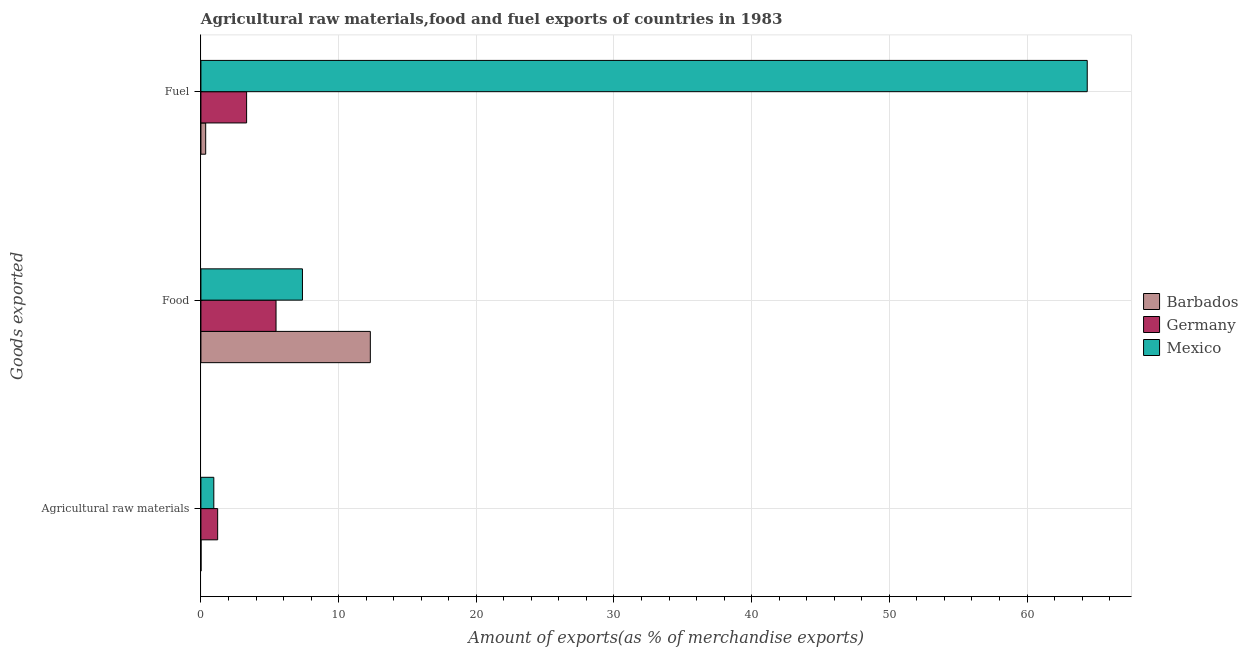How many different coloured bars are there?
Give a very brief answer. 3. Are the number of bars per tick equal to the number of legend labels?
Offer a very short reply. Yes. Are the number of bars on each tick of the Y-axis equal?
Provide a short and direct response. Yes. What is the label of the 1st group of bars from the top?
Offer a terse response. Fuel. What is the percentage of raw materials exports in Mexico?
Provide a succinct answer. 0.94. Across all countries, what is the maximum percentage of raw materials exports?
Make the answer very short. 1.22. Across all countries, what is the minimum percentage of raw materials exports?
Your response must be concise. 0.01. In which country was the percentage of fuel exports maximum?
Offer a terse response. Mexico. In which country was the percentage of fuel exports minimum?
Your response must be concise. Barbados. What is the total percentage of raw materials exports in the graph?
Make the answer very short. 2.16. What is the difference between the percentage of raw materials exports in Germany and that in Barbados?
Offer a very short reply. 1.21. What is the difference between the percentage of fuel exports in Mexico and the percentage of raw materials exports in Germany?
Your response must be concise. 63.15. What is the average percentage of food exports per country?
Provide a short and direct response. 8.38. What is the difference between the percentage of fuel exports and percentage of raw materials exports in Germany?
Provide a short and direct response. 2.1. In how many countries, is the percentage of fuel exports greater than 54 %?
Keep it short and to the point. 1. What is the ratio of the percentage of fuel exports in Germany to that in Mexico?
Provide a short and direct response. 0.05. What is the difference between the highest and the second highest percentage of raw materials exports?
Your answer should be compact. 0.28. What is the difference between the highest and the lowest percentage of food exports?
Provide a succinct answer. 6.85. Are all the bars in the graph horizontal?
Provide a short and direct response. Yes. Are the values on the major ticks of X-axis written in scientific E-notation?
Your answer should be very brief. No. How are the legend labels stacked?
Your response must be concise. Vertical. What is the title of the graph?
Ensure brevity in your answer.  Agricultural raw materials,food and fuel exports of countries in 1983. What is the label or title of the X-axis?
Your response must be concise. Amount of exports(as % of merchandise exports). What is the label or title of the Y-axis?
Keep it short and to the point. Goods exported. What is the Amount of exports(as % of merchandise exports) of Barbados in Agricultural raw materials?
Give a very brief answer. 0.01. What is the Amount of exports(as % of merchandise exports) of Germany in Agricultural raw materials?
Ensure brevity in your answer.  1.22. What is the Amount of exports(as % of merchandise exports) in Mexico in Agricultural raw materials?
Provide a short and direct response. 0.94. What is the Amount of exports(as % of merchandise exports) of Barbados in Food?
Give a very brief answer. 12.3. What is the Amount of exports(as % of merchandise exports) of Germany in Food?
Make the answer very short. 5.46. What is the Amount of exports(as % of merchandise exports) of Mexico in Food?
Provide a succinct answer. 7.37. What is the Amount of exports(as % of merchandise exports) of Barbados in Fuel?
Your response must be concise. 0.35. What is the Amount of exports(as % of merchandise exports) of Germany in Fuel?
Offer a terse response. 3.32. What is the Amount of exports(as % of merchandise exports) in Mexico in Fuel?
Offer a terse response. 64.37. Across all Goods exported, what is the maximum Amount of exports(as % of merchandise exports) of Barbados?
Provide a succinct answer. 12.3. Across all Goods exported, what is the maximum Amount of exports(as % of merchandise exports) of Germany?
Ensure brevity in your answer.  5.46. Across all Goods exported, what is the maximum Amount of exports(as % of merchandise exports) of Mexico?
Give a very brief answer. 64.37. Across all Goods exported, what is the minimum Amount of exports(as % of merchandise exports) of Barbados?
Provide a short and direct response. 0.01. Across all Goods exported, what is the minimum Amount of exports(as % of merchandise exports) of Germany?
Your answer should be very brief. 1.22. Across all Goods exported, what is the minimum Amount of exports(as % of merchandise exports) of Mexico?
Provide a short and direct response. 0.94. What is the total Amount of exports(as % of merchandise exports) of Barbados in the graph?
Provide a short and direct response. 12.66. What is the total Amount of exports(as % of merchandise exports) in Germany in the graph?
Your answer should be compact. 9.99. What is the total Amount of exports(as % of merchandise exports) in Mexico in the graph?
Your response must be concise. 72.68. What is the difference between the Amount of exports(as % of merchandise exports) in Barbados in Agricultural raw materials and that in Food?
Your response must be concise. -12.3. What is the difference between the Amount of exports(as % of merchandise exports) of Germany in Agricultural raw materials and that in Food?
Make the answer very short. -4.24. What is the difference between the Amount of exports(as % of merchandise exports) of Mexico in Agricultural raw materials and that in Food?
Give a very brief answer. -6.44. What is the difference between the Amount of exports(as % of merchandise exports) in Barbados in Agricultural raw materials and that in Fuel?
Offer a very short reply. -0.34. What is the difference between the Amount of exports(as % of merchandise exports) of Germany in Agricultural raw materials and that in Fuel?
Give a very brief answer. -2.1. What is the difference between the Amount of exports(as % of merchandise exports) of Mexico in Agricultural raw materials and that in Fuel?
Make the answer very short. -63.43. What is the difference between the Amount of exports(as % of merchandise exports) in Barbados in Food and that in Fuel?
Your answer should be compact. 11.96. What is the difference between the Amount of exports(as % of merchandise exports) in Germany in Food and that in Fuel?
Keep it short and to the point. 2.14. What is the difference between the Amount of exports(as % of merchandise exports) in Mexico in Food and that in Fuel?
Provide a short and direct response. -57. What is the difference between the Amount of exports(as % of merchandise exports) of Barbados in Agricultural raw materials and the Amount of exports(as % of merchandise exports) of Germany in Food?
Your answer should be compact. -5.45. What is the difference between the Amount of exports(as % of merchandise exports) in Barbados in Agricultural raw materials and the Amount of exports(as % of merchandise exports) in Mexico in Food?
Give a very brief answer. -7.37. What is the difference between the Amount of exports(as % of merchandise exports) in Germany in Agricultural raw materials and the Amount of exports(as % of merchandise exports) in Mexico in Food?
Give a very brief answer. -6.16. What is the difference between the Amount of exports(as % of merchandise exports) in Barbados in Agricultural raw materials and the Amount of exports(as % of merchandise exports) in Germany in Fuel?
Your response must be concise. -3.31. What is the difference between the Amount of exports(as % of merchandise exports) in Barbados in Agricultural raw materials and the Amount of exports(as % of merchandise exports) in Mexico in Fuel?
Offer a very short reply. -64.36. What is the difference between the Amount of exports(as % of merchandise exports) in Germany in Agricultural raw materials and the Amount of exports(as % of merchandise exports) in Mexico in Fuel?
Your response must be concise. -63.15. What is the difference between the Amount of exports(as % of merchandise exports) of Barbados in Food and the Amount of exports(as % of merchandise exports) of Germany in Fuel?
Provide a succinct answer. 8.99. What is the difference between the Amount of exports(as % of merchandise exports) of Barbados in Food and the Amount of exports(as % of merchandise exports) of Mexico in Fuel?
Your answer should be very brief. -52.07. What is the difference between the Amount of exports(as % of merchandise exports) in Germany in Food and the Amount of exports(as % of merchandise exports) in Mexico in Fuel?
Provide a succinct answer. -58.91. What is the average Amount of exports(as % of merchandise exports) in Barbados per Goods exported?
Your answer should be very brief. 4.22. What is the average Amount of exports(as % of merchandise exports) of Germany per Goods exported?
Make the answer very short. 3.33. What is the average Amount of exports(as % of merchandise exports) in Mexico per Goods exported?
Ensure brevity in your answer.  24.23. What is the difference between the Amount of exports(as % of merchandise exports) of Barbados and Amount of exports(as % of merchandise exports) of Germany in Agricultural raw materials?
Make the answer very short. -1.21. What is the difference between the Amount of exports(as % of merchandise exports) of Barbados and Amount of exports(as % of merchandise exports) of Mexico in Agricultural raw materials?
Your answer should be compact. -0.93. What is the difference between the Amount of exports(as % of merchandise exports) of Germany and Amount of exports(as % of merchandise exports) of Mexico in Agricultural raw materials?
Your answer should be compact. 0.28. What is the difference between the Amount of exports(as % of merchandise exports) in Barbados and Amount of exports(as % of merchandise exports) in Germany in Food?
Keep it short and to the point. 6.85. What is the difference between the Amount of exports(as % of merchandise exports) of Barbados and Amount of exports(as % of merchandise exports) of Mexico in Food?
Give a very brief answer. 4.93. What is the difference between the Amount of exports(as % of merchandise exports) of Germany and Amount of exports(as % of merchandise exports) of Mexico in Food?
Ensure brevity in your answer.  -1.92. What is the difference between the Amount of exports(as % of merchandise exports) of Barbados and Amount of exports(as % of merchandise exports) of Germany in Fuel?
Offer a very short reply. -2.97. What is the difference between the Amount of exports(as % of merchandise exports) of Barbados and Amount of exports(as % of merchandise exports) of Mexico in Fuel?
Make the answer very short. -64.02. What is the difference between the Amount of exports(as % of merchandise exports) of Germany and Amount of exports(as % of merchandise exports) of Mexico in Fuel?
Offer a very short reply. -61.05. What is the ratio of the Amount of exports(as % of merchandise exports) in Barbados in Agricultural raw materials to that in Food?
Make the answer very short. 0. What is the ratio of the Amount of exports(as % of merchandise exports) of Germany in Agricultural raw materials to that in Food?
Your answer should be compact. 0.22. What is the ratio of the Amount of exports(as % of merchandise exports) in Mexico in Agricultural raw materials to that in Food?
Give a very brief answer. 0.13. What is the ratio of the Amount of exports(as % of merchandise exports) of Barbados in Agricultural raw materials to that in Fuel?
Your answer should be very brief. 0.02. What is the ratio of the Amount of exports(as % of merchandise exports) in Germany in Agricultural raw materials to that in Fuel?
Make the answer very short. 0.37. What is the ratio of the Amount of exports(as % of merchandise exports) of Mexico in Agricultural raw materials to that in Fuel?
Make the answer very short. 0.01. What is the ratio of the Amount of exports(as % of merchandise exports) in Barbados in Food to that in Fuel?
Keep it short and to the point. 35.49. What is the ratio of the Amount of exports(as % of merchandise exports) of Germany in Food to that in Fuel?
Keep it short and to the point. 1.64. What is the ratio of the Amount of exports(as % of merchandise exports) in Mexico in Food to that in Fuel?
Offer a very short reply. 0.11. What is the difference between the highest and the second highest Amount of exports(as % of merchandise exports) of Barbados?
Ensure brevity in your answer.  11.96. What is the difference between the highest and the second highest Amount of exports(as % of merchandise exports) in Germany?
Ensure brevity in your answer.  2.14. What is the difference between the highest and the second highest Amount of exports(as % of merchandise exports) in Mexico?
Your response must be concise. 57. What is the difference between the highest and the lowest Amount of exports(as % of merchandise exports) of Barbados?
Your answer should be compact. 12.3. What is the difference between the highest and the lowest Amount of exports(as % of merchandise exports) of Germany?
Keep it short and to the point. 4.24. What is the difference between the highest and the lowest Amount of exports(as % of merchandise exports) in Mexico?
Ensure brevity in your answer.  63.43. 